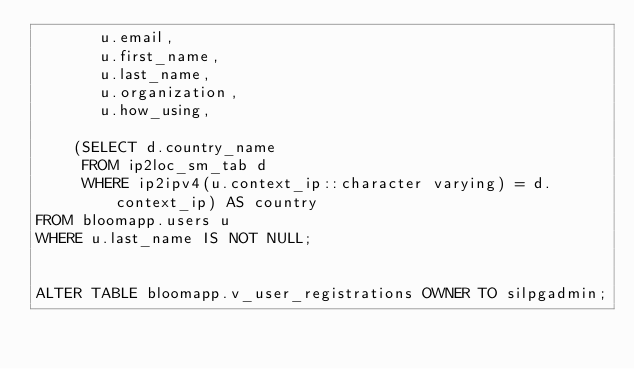Convert code to text. <code><loc_0><loc_0><loc_500><loc_500><_SQL_>       u.email,
       u.first_name,
       u.last_name,
       u.organization,
       u.how_using,

    (SELECT d.country_name
     FROM ip2loc_sm_tab d
     WHERE ip2ipv4(u.context_ip::character varying) = d.context_ip) AS country
FROM bloomapp.users u
WHERE u.last_name IS NOT NULL;


ALTER TABLE bloomapp.v_user_registrations OWNER TO silpgadmin;

</code> 